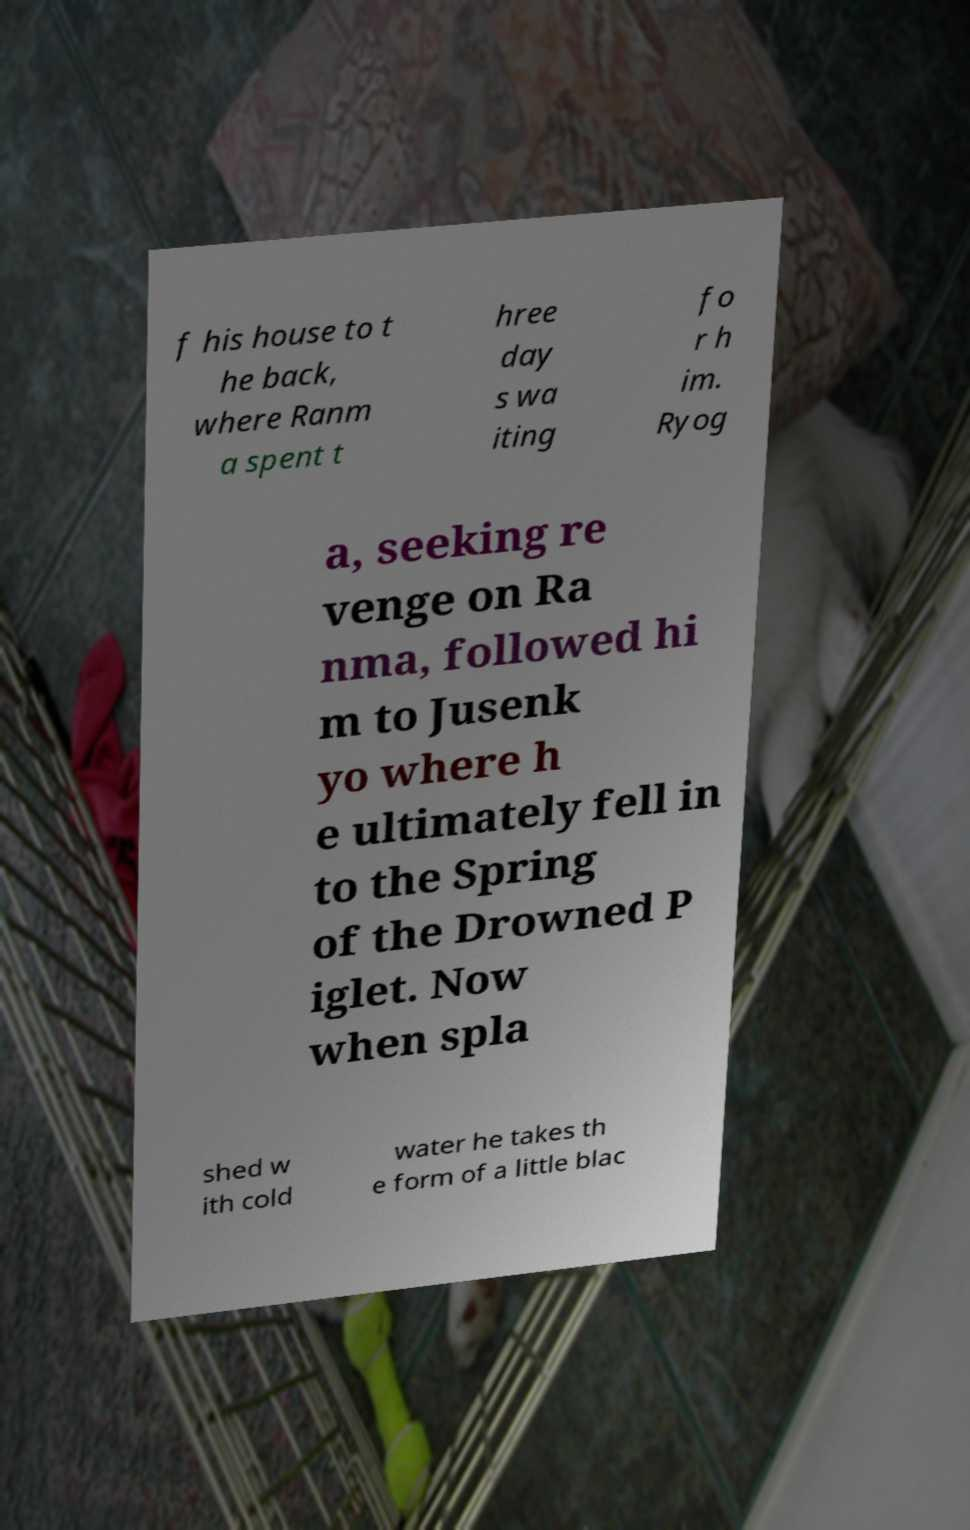Can you read and provide the text displayed in the image?This photo seems to have some interesting text. Can you extract and type it out for me? f his house to t he back, where Ranm a spent t hree day s wa iting fo r h im. Ryog a, seeking re venge on Ra nma, followed hi m to Jusenk yo where h e ultimately fell in to the Spring of the Drowned P iglet. Now when spla shed w ith cold water he takes th e form of a little blac 